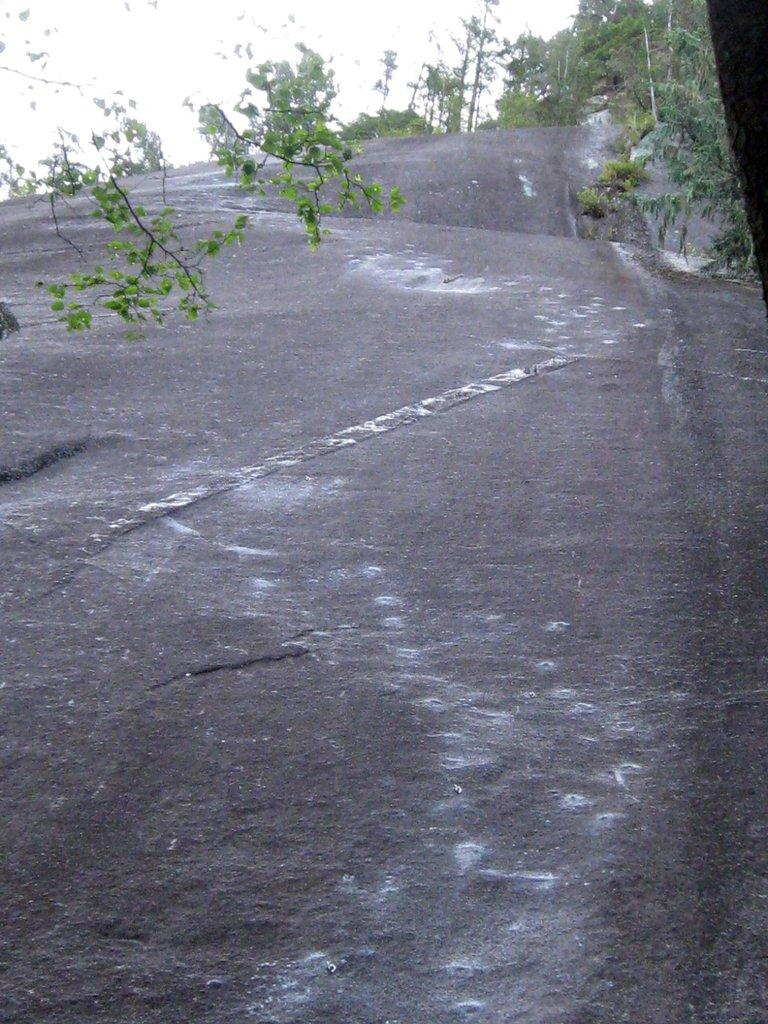What can be seen in the background of the image? The sky is visible in the image, and there are trees in the background. Can you describe the time of day when the image was taken? The image was taken during the day. How many oranges are hanging from the trees in the image? There are no oranges visible in the image; only trees are present. What type of sugar is being used to sweeten the rain in the image? There is no rain or sugar present in the image. 